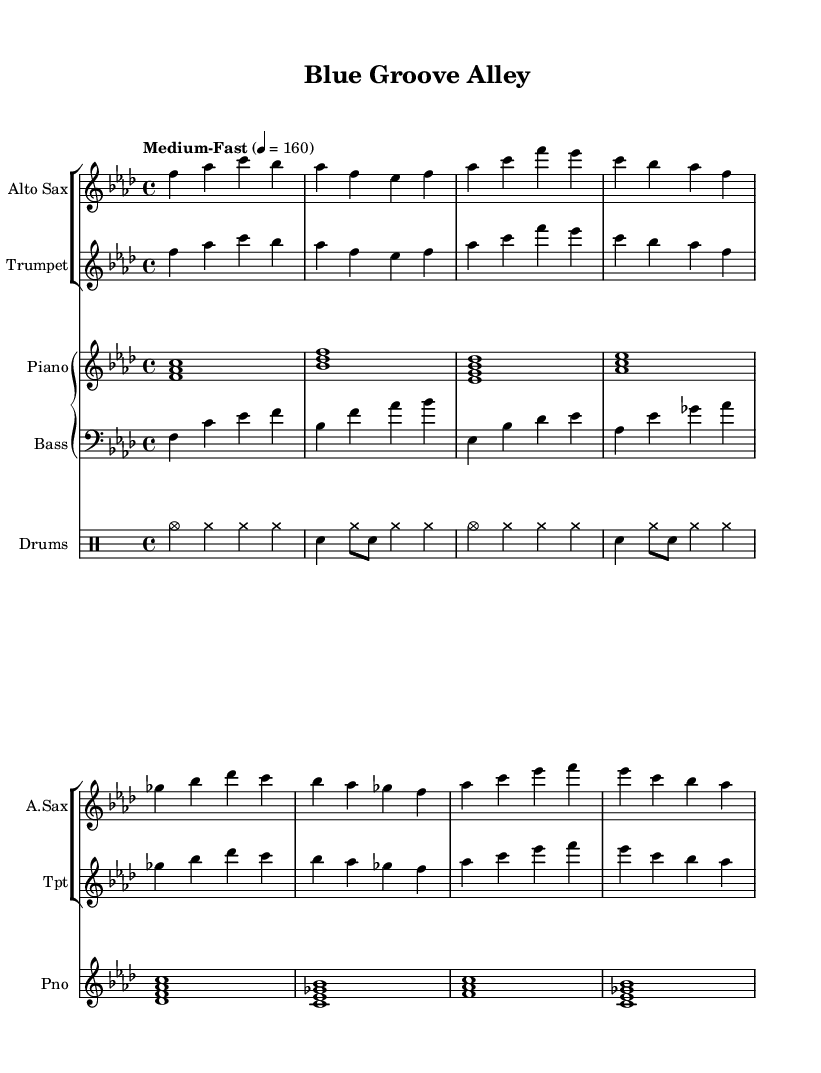What is the key signature of this music? The key signature is indicated at the beginning of the piece. In this sheet music, it shows four flats, which represents the key signature of F minor.
Answer: F minor What is the time signature of this music? The time signature is displayed at the beginning, indicating how many beats are in each measure. Here, it shows 4 over 4, which means there are four beats per measure.
Answer: 4/4 What is the tempo indication for this piece? The tempo marking appears in the music as "Medium-Fast" with a metronome marking of 160 beats per minute. This indicates how quickly the piece should be played.
Answer: 160 How many instruments are featured in this piece? Counting the staff groups in the score, there are four distinct staves for different instruments: saxophone, trumpet, piano, and bass, along with a drum staff. Thus, there are five instruments featured in total.
Answer: Five What is the main style of this composition? This piece is in the style of hard bop, which is evident in the soulful melodies and driving rhythms typical of the genre. This can be inferred from the rhythmic patterns and melodic structure present throughout the score.
Answer: Hard bop Which instrument plays the highest pitch in this arrangement? By looking at the range of the instruments on the staff, the saxophone typically plays at a higher pitch than the trumpet and other accompanying instruments. Hence, the alto saxophone has the highest pitch in this arrangement.
Answer: Alto saxophone 